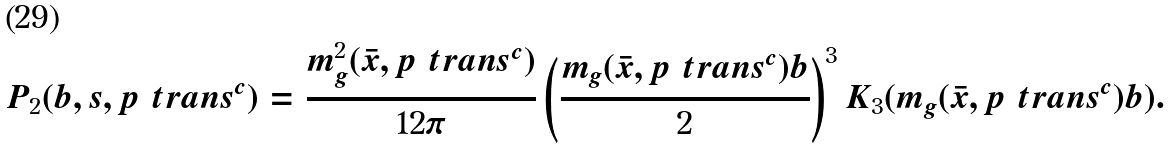Convert formula to latex. <formula><loc_0><loc_0><loc_500><loc_500>P _ { 2 } ( b , s , p _ { \ } t r a n s ^ { c } ) = \frac { m _ { g } ^ { 2 } ( \bar { x } , p _ { \ } t r a n s ^ { c } ) } { 1 2 \pi } \left ( \frac { m _ { g } ( \bar { x } , p _ { \ } t r a n s ^ { c } ) b } { 2 } \right ) ^ { 3 } K _ { 3 } ( m _ { g } ( \bar { x } , p _ { \ } t r a n s ^ { c } ) b ) .</formula> 